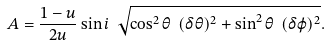<formula> <loc_0><loc_0><loc_500><loc_500>A = \frac { 1 - u } { 2 u } \sin i \ \sqrt { \cos ^ { 2 } \theta \ ( \delta \theta ) ^ { 2 } + \sin ^ { 2 } \theta \ ( \delta \varphi ) ^ { 2 } } .</formula> 